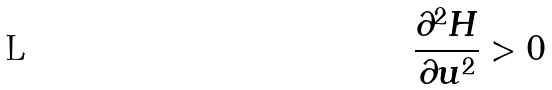<formula> <loc_0><loc_0><loc_500><loc_500>\frac { \partial ^ { 2 } H } { \partial u ^ { 2 } } > 0</formula> 